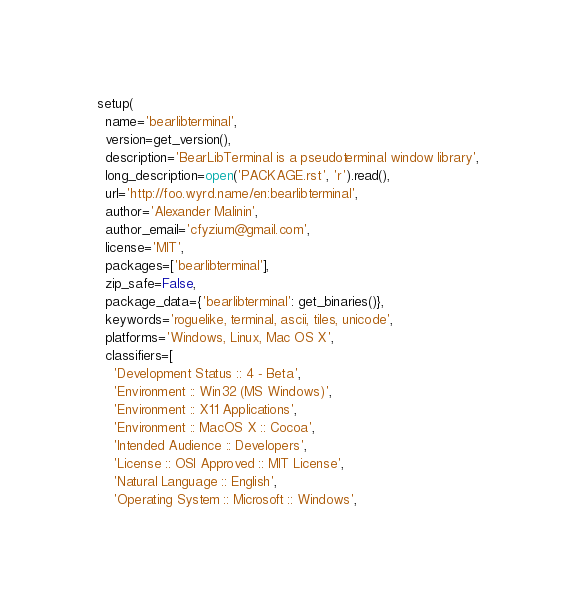<code> <loc_0><loc_0><loc_500><loc_500><_Python_>
setup(
  name='bearlibterminal',
  version=get_version(),
  description='BearLibTerminal is a pseudoterminal window library',
  long_description=open('PACKAGE.rst', 'r').read(),
  url='http://foo.wyrd.name/en:bearlibterminal',
  author='Alexander Malinin',
  author_email='cfyzium@gmail.com',
  license='MIT',
  packages=['bearlibterminal'],
  zip_safe=False,
  package_data={'bearlibterminal': get_binaries()},
  keywords='roguelike, terminal, ascii, tiles, unicode',
  platforms='Windows, Linux, Mac OS X',
  classifiers=[
    'Development Status :: 4 - Beta',
    'Environment :: Win32 (MS Windows)',
    'Environment :: X11 Applications',
    'Environment :: MacOS X :: Cocoa',
    'Intended Audience :: Developers',
    'License :: OSI Approved :: MIT License',
    'Natural Language :: English',
    'Operating System :: Microsoft :: Windows',</code> 